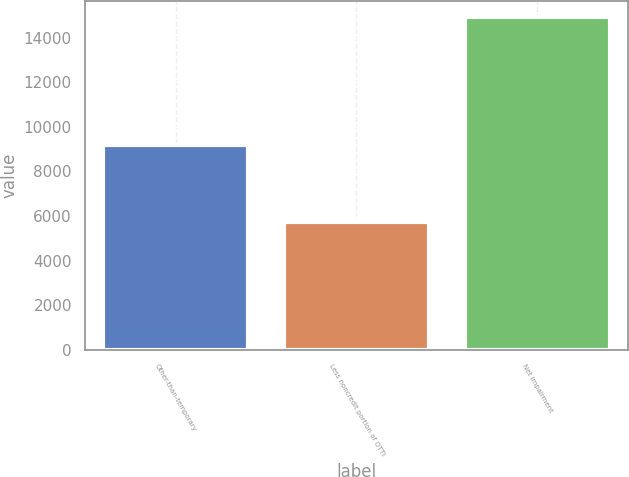<chart> <loc_0><loc_0><loc_500><loc_500><bar_chart><fcel>Other-than-temporary<fcel>Less noncredit portion of OTTI<fcel>Net impairment<nl><fcel>9190<fcel>5717<fcel>14907<nl></chart> 